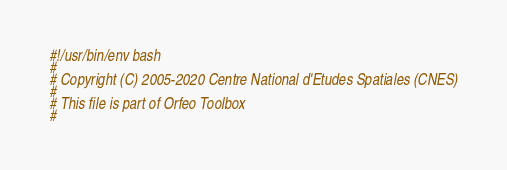Convert code to text. <code><loc_0><loc_0><loc_500><loc_500><_Bash_>#!/usr/bin/env bash
#
# Copyright (C) 2005-2020 Centre National d'Etudes Spatiales (CNES)
#
# This file is part of Orfeo Toolbox
#</code> 